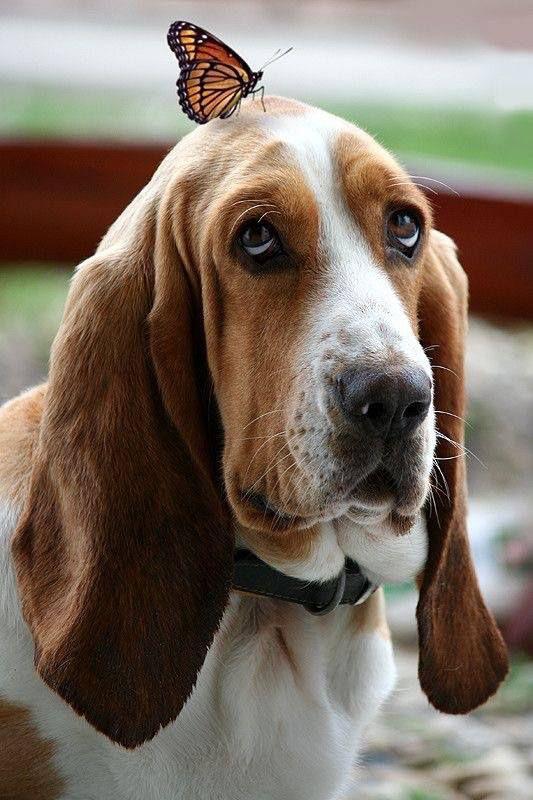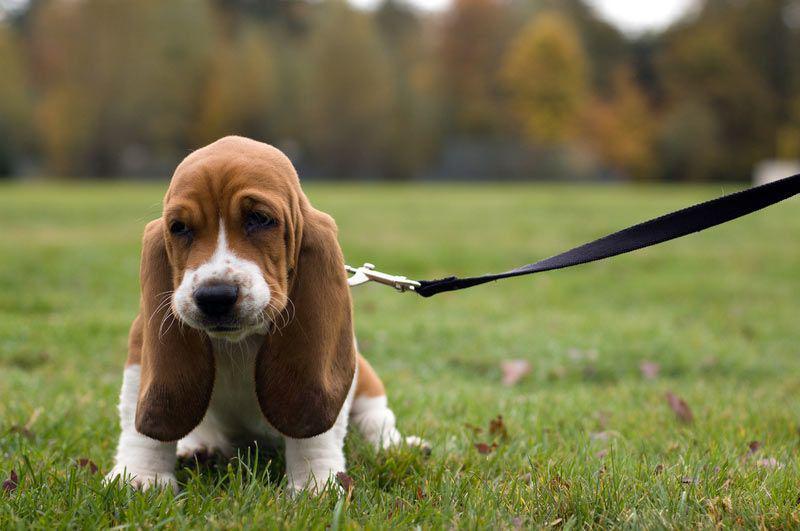The first image is the image on the left, the second image is the image on the right. Evaluate the accuracy of this statement regarding the images: "One of the dogs is sitting on a wooden surface.". Is it true? Answer yes or no. No. 